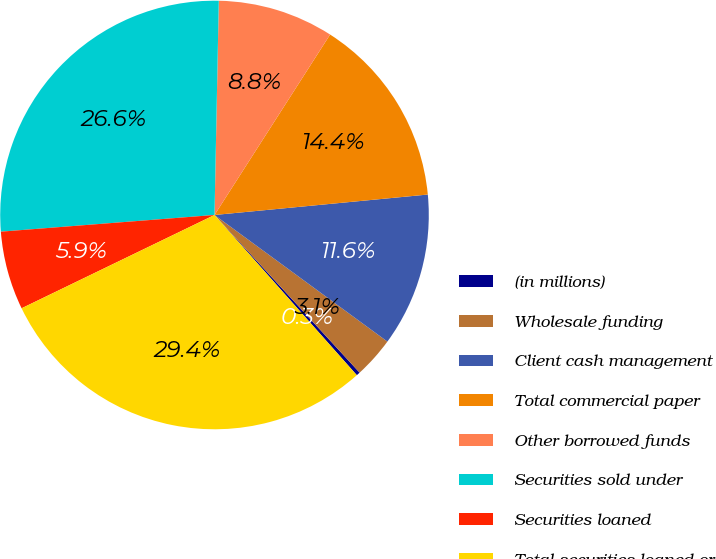Convert chart to OTSL. <chart><loc_0><loc_0><loc_500><loc_500><pie_chart><fcel>(in millions)<fcel>Wholesale funding<fcel>Client cash management<fcel>Total commercial paper<fcel>Other borrowed funds<fcel>Securities sold under<fcel>Securities loaned<fcel>Total securities loaned or<nl><fcel>0.28%<fcel>3.1%<fcel>11.58%<fcel>14.41%<fcel>8.75%<fcel>26.56%<fcel>5.93%<fcel>29.39%<nl></chart> 